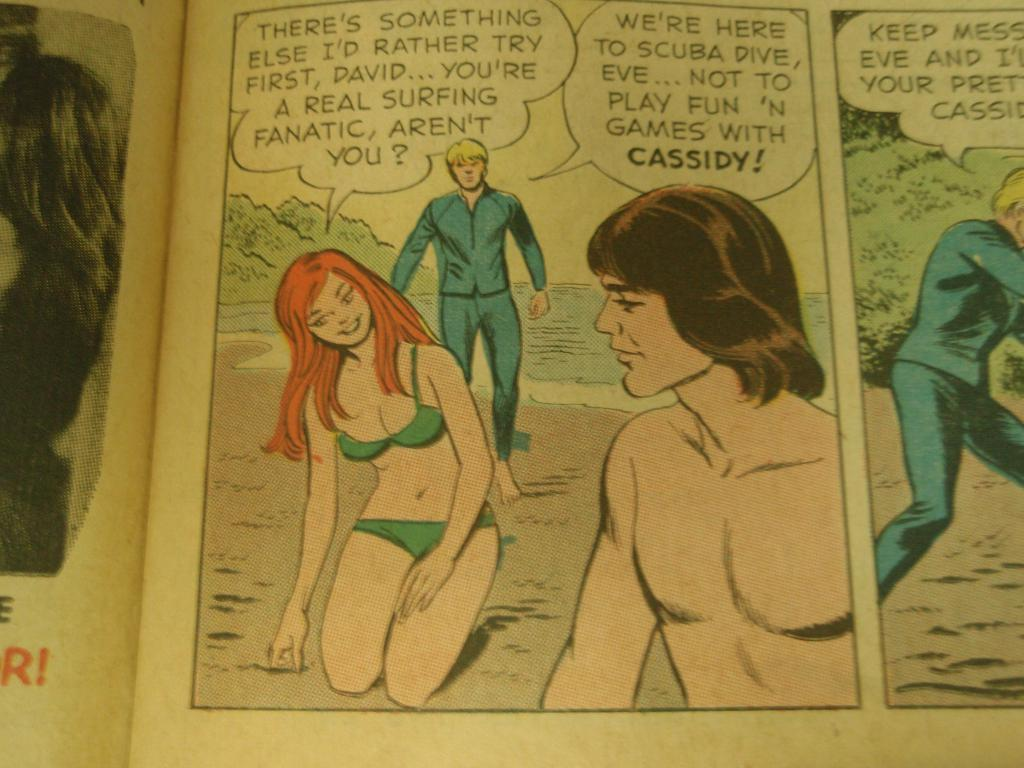Provide a one-sentence caption for the provided image. Comic book about men and a girl that are surfing. 